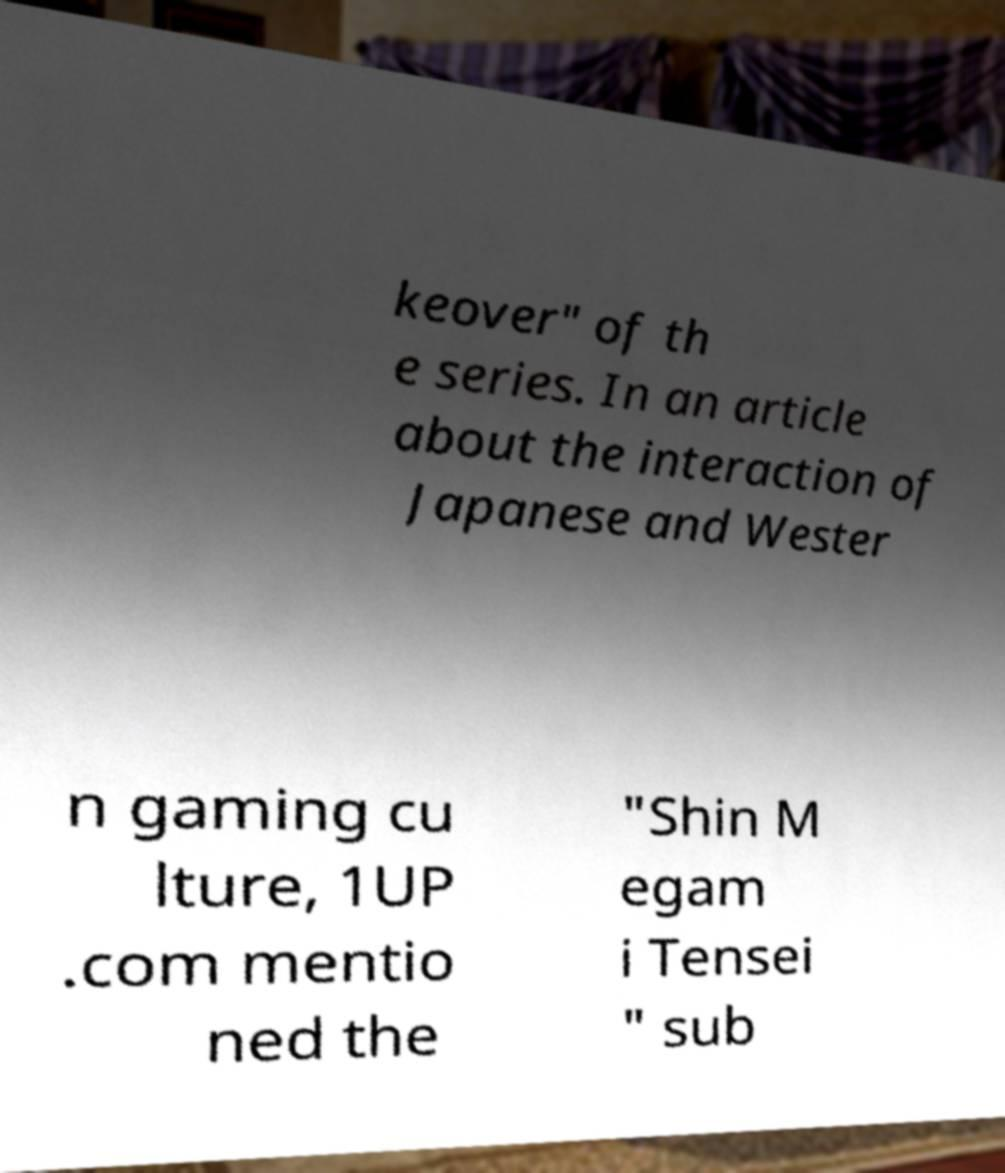What messages or text are displayed in this image? I need them in a readable, typed format. keover" of th e series. In an article about the interaction of Japanese and Wester n gaming cu lture, 1UP .com mentio ned the "Shin M egam i Tensei " sub 